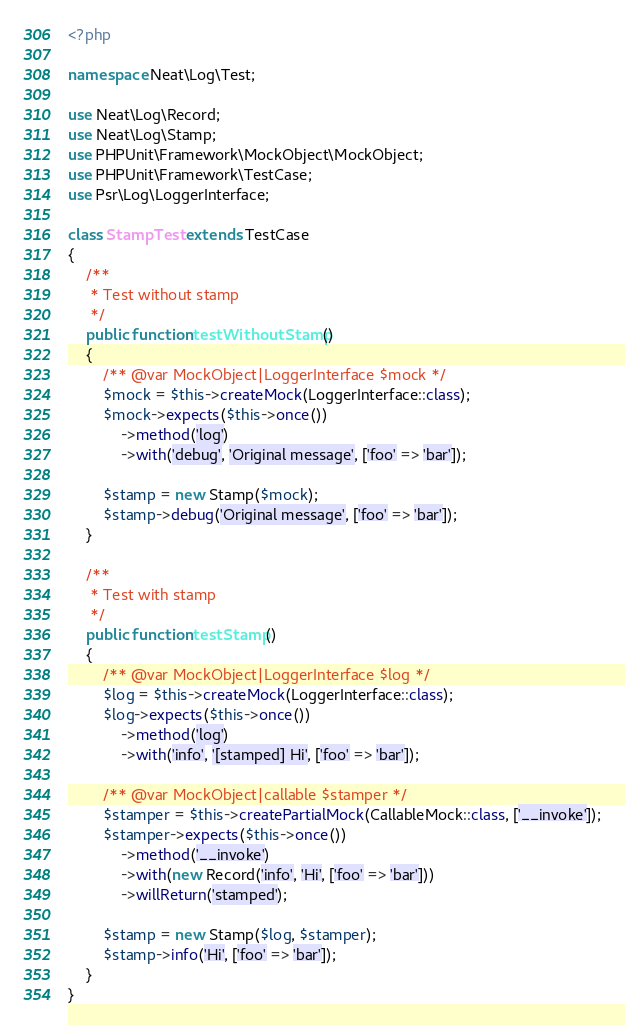Convert code to text. <code><loc_0><loc_0><loc_500><loc_500><_PHP_><?php

namespace Neat\Log\Test;

use Neat\Log\Record;
use Neat\Log\Stamp;
use PHPUnit\Framework\MockObject\MockObject;
use PHPUnit\Framework\TestCase;
use Psr\Log\LoggerInterface;

class StampTest extends TestCase
{
    /**
     * Test without stamp
     */
    public function testWithoutStamp()
    {
        /** @var MockObject|LoggerInterface $mock */
        $mock = $this->createMock(LoggerInterface::class);
        $mock->expects($this->once())
            ->method('log')
            ->with('debug', 'Original message', ['foo' => 'bar']);

        $stamp = new Stamp($mock);
        $stamp->debug('Original message', ['foo' => 'bar']);
    }

    /**
     * Test with stamp
     */
    public function testStamp()
    {
        /** @var MockObject|LoggerInterface $log */
        $log = $this->createMock(LoggerInterface::class);
        $log->expects($this->once())
            ->method('log')
            ->with('info', '[stamped] Hi', ['foo' => 'bar']);

        /** @var MockObject|callable $stamper */
        $stamper = $this->createPartialMock(CallableMock::class, ['__invoke']);
        $stamper->expects($this->once())
            ->method('__invoke')
            ->with(new Record('info', 'Hi', ['foo' => 'bar']))
            ->willReturn('stamped');

        $stamp = new Stamp($log, $stamper);
        $stamp->info('Hi', ['foo' => 'bar']);
    }
}
</code> 